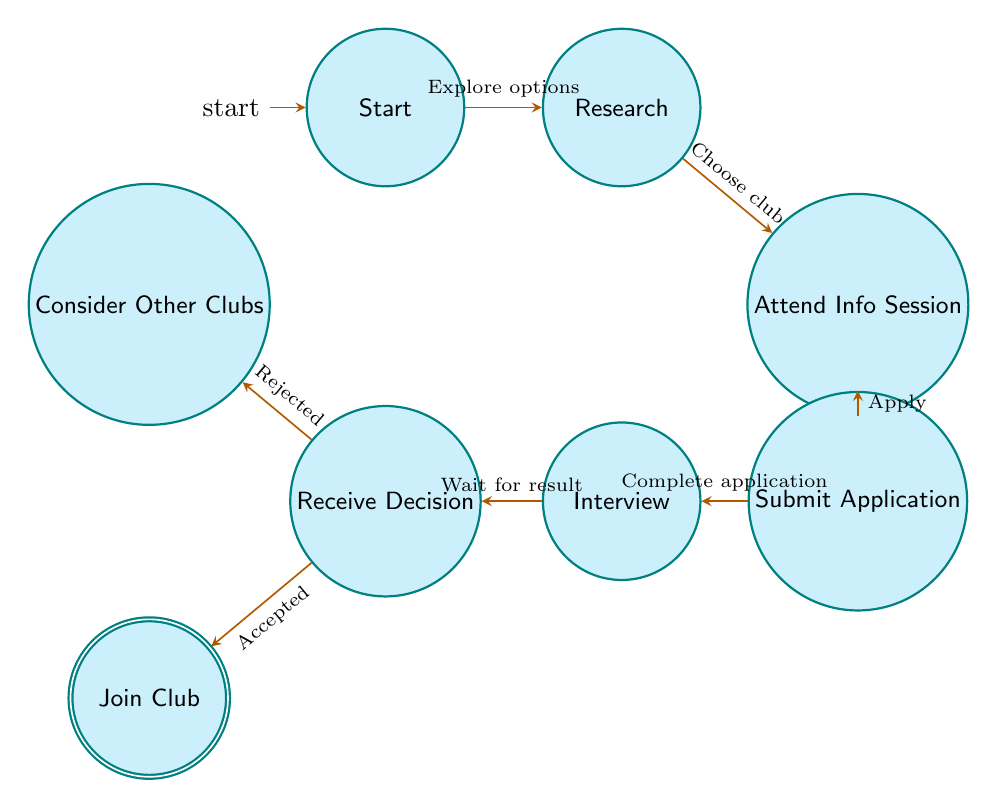What's the total number of states in the diagram? The diagram lists eight states: Start, Research, Attend Info Session, Submit Application, Interview, Receive Decision, Join Club, and Consider Other Clubs. Counting these gives a total of eight states.
Answer: 8 What is the final state when the application is accepted? According to the diagram, if the applicant is accepted after the decision phase, the next state is Join Club, indicating that the individual officially joins the club.
Answer: Join Club From which state does a student move to the Consider Other Clubs state? The student moves to the Consider Other Clubs state from the Receive Decision state if they receive a rejection regarding their application to the club.
Answer: Receive Decision How many transitions are there leading into the Interview state? The Interview state has only one transition leading into it, which comes from the Submit Application state when the student has completed their application.
Answer: 1 What happens after the Attend Info Session? After attending the information session, the student must decide to apply to the club, which transitions them to the Submit Application state.
Answer: Submit Application If a student is rejected, what is the next state they can enter? If a student receives a rejection, they can enter the Consider Other Clubs state to explore other options for clubs at AASTMT.
Answer: Consider Other Clubs What is the relationship between the Join Club and Receive Decision states? Join Club is the next step after receiving a decision, specifically when the decision is acceptance, establishing a direct flow from Receive Decision to Join Club.
Answer: Accepted Which state immediately follows Research? The state that immediately follows Research is Attend Info Session, as per the flow laid out in the diagram.
Answer: Attend Info Session 